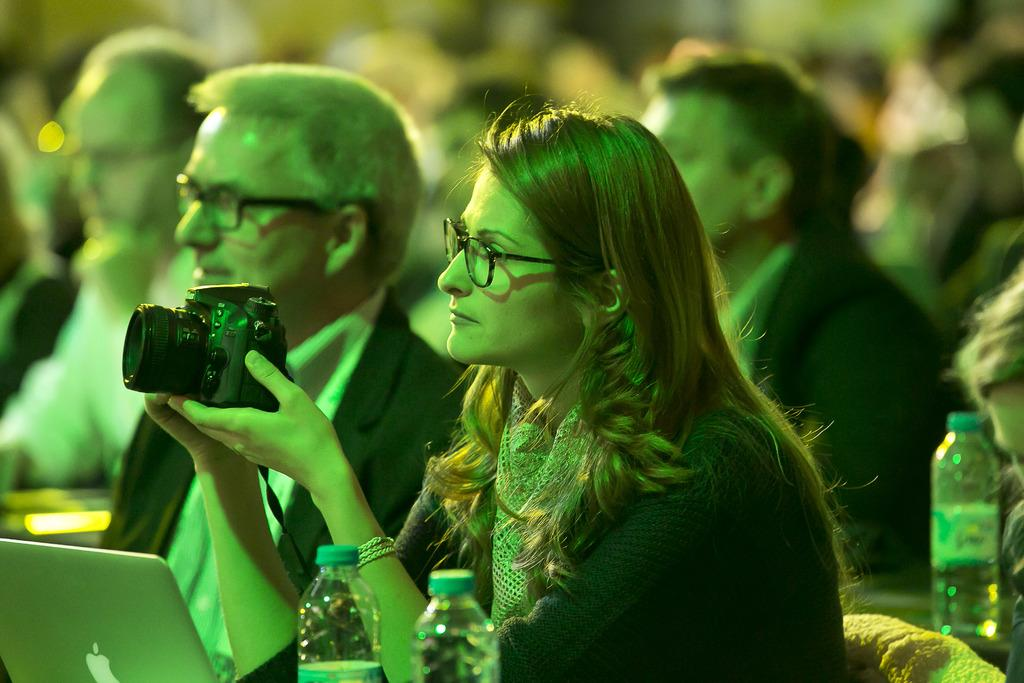What are the people in the image doing? The people in the image are seated. What is the man holding in the image? The man is holding a camera in the image. What items can be seen for hydration purposes in the image? There are water bottles visible in the image. What electronic device is present in the image? A laptop is present in the image. What type of soup is being served in the image? There is no soup present in the image. What is the profit margin of the people in the image? The image does not provide any information about profit margins, as it focuses on the people's activities and the objects around them. 